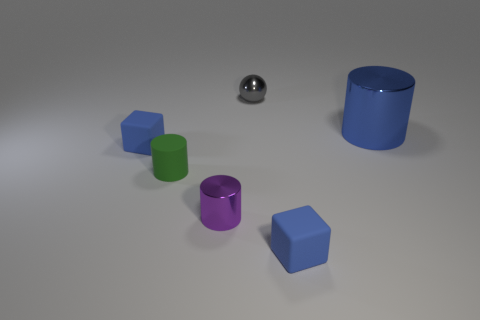Do the gray metal sphere and the rubber cylinder have the same size? Based on the image, the gray metal sphere and the blue rubber cylinder appear to be of different sizes. The cylinder's diameter seems larger than the sphere's. Without exact measurements, it's not possible to determine their sizes precisely, but visually, they are not the same. 